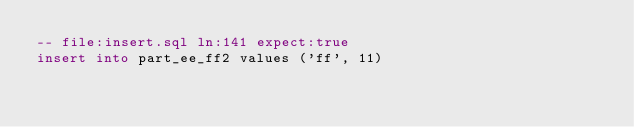Convert code to text. <code><loc_0><loc_0><loc_500><loc_500><_SQL_>-- file:insert.sql ln:141 expect:true
insert into part_ee_ff2 values ('ff', 11)
</code> 